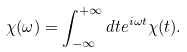<formula> <loc_0><loc_0><loc_500><loc_500>\chi ( \omega ) = \int _ { - \infty } ^ { + \infty } d t e ^ { i \omega t } \chi ( t ) .</formula> 